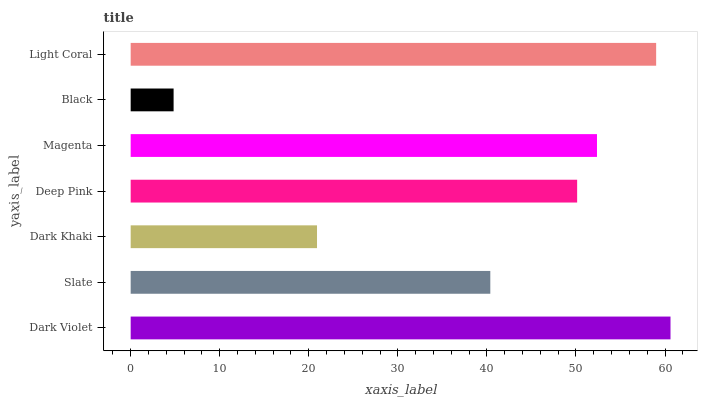Is Black the minimum?
Answer yes or no. Yes. Is Dark Violet the maximum?
Answer yes or no. Yes. Is Slate the minimum?
Answer yes or no. No. Is Slate the maximum?
Answer yes or no. No. Is Dark Violet greater than Slate?
Answer yes or no. Yes. Is Slate less than Dark Violet?
Answer yes or no. Yes. Is Slate greater than Dark Violet?
Answer yes or no. No. Is Dark Violet less than Slate?
Answer yes or no. No. Is Deep Pink the high median?
Answer yes or no. Yes. Is Deep Pink the low median?
Answer yes or no. Yes. Is Dark Violet the high median?
Answer yes or no. No. Is Dark Khaki the low median?
Answer yes or no. No. 